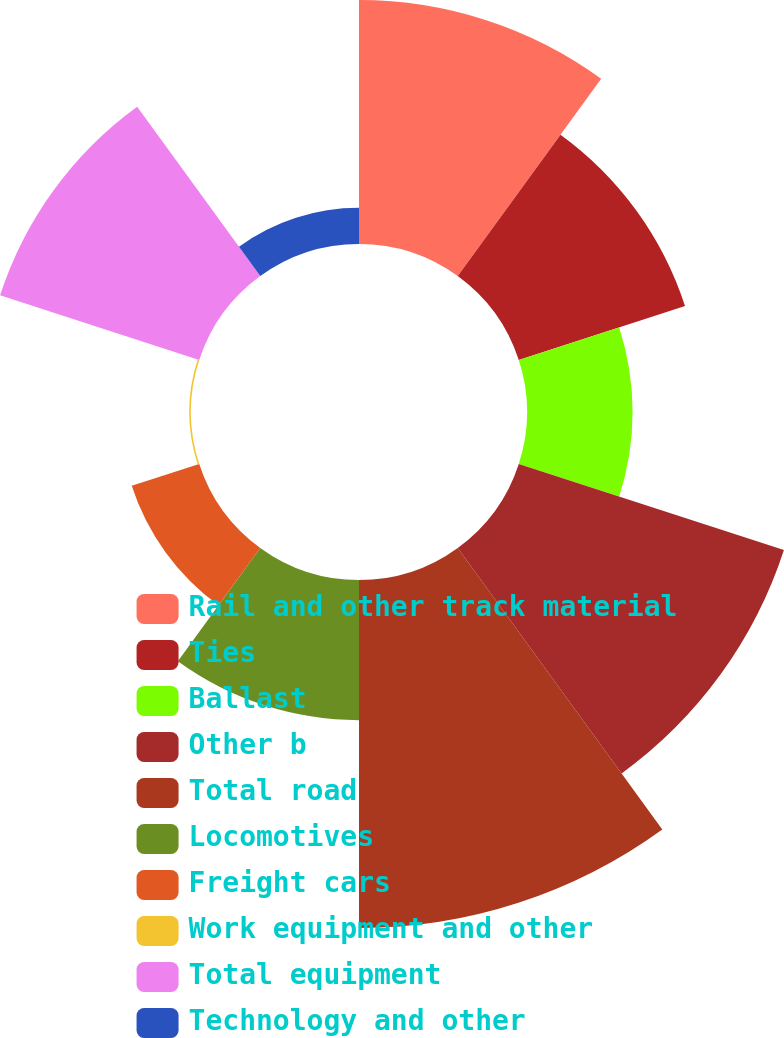Convert chart to OTSL. <chart><loc_0><loc_0><loc_500><loc_500><pie_chart><fcel>Rail and other track material<fcel>Ties<fcel>Ballast<fcel>Other b<fcel>Total road<fcel>Locomotives<fcel>Freight cars<fcel>Work equipment and other<fcel>Total equipment<fcel>Technology and other<nl><fcel>15.16%<fcel>10.86%<fcel>6.56%<fcel>17.32%<fcel>21.62%<fcel>8.71%<fcel>4.41%<fcel>0.1%<fcel>13.01%<fcel>2.25%<nl></chart> 